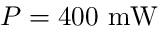<formula> <loc_0><loc_0><loc_500><loc_500>P = 4 0 0 m W</formula> 